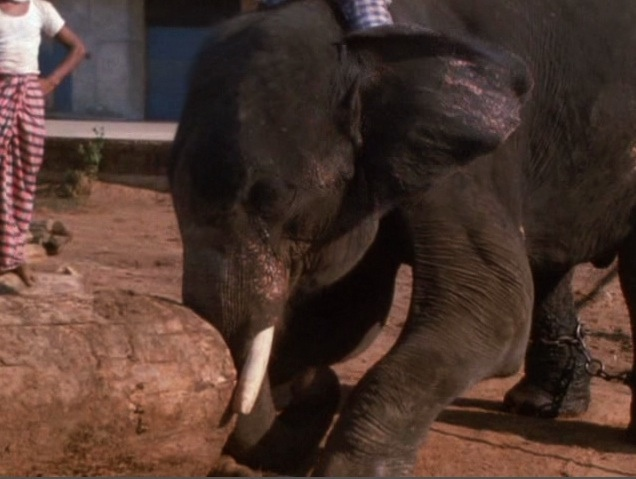Describe the objects in this image and their specific colors. I can see elephant in black, maroon, and brown tones and people in maroon, brown, lightgray, and lightpink tones in this image. 